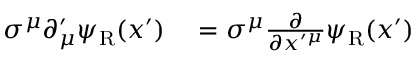<formula> <loc_0><loc_0><loc_500><loc_500>\begin{array} { r l } { \sigma ^ { \mu } \partial _ { \mu } ^ { \prime } \psi _ { R } ( x ^ { \prime } ) } & = \sigma ^ { \mu } { \frac { \partial } { \partial x ^ { \prime \mu } } } \psi _ { R } ( x ^ { \prime } ) } \end{array}</formula> 